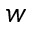<formula> <loc_0><loc_0><loc_500><loc_500>w</formula> 